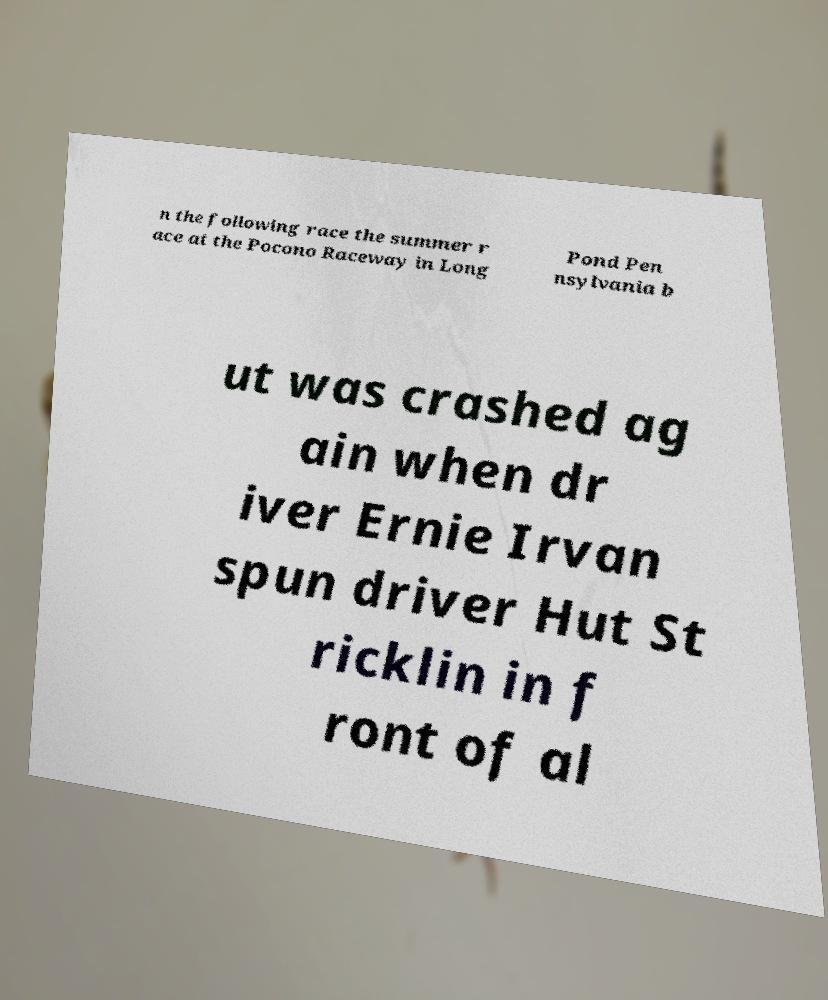I need the written content from this picture converted into text. Can you do that? n the following race the summer r ace at the Pocono Raceway in Long Pond Pen nsylvania b ut was crashed ag ain when dr iver Ernie Irvan spun driver Hut St ricklin in f ront of al 